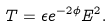Convert formula to latex. <formula><loc_0><loc_0><loc_500><loc_500>T = \epsilon e ^ { - 2 \phi } E ^ { 2 } .</formula> 